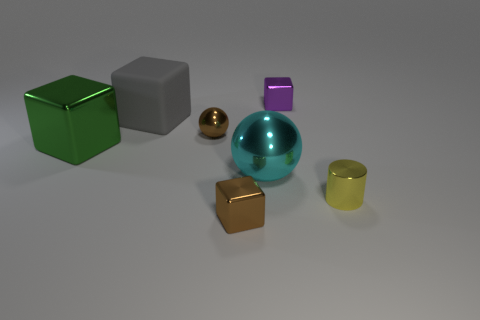What is the material of the brown object that is behind the shiny thing that is on the left side of the brown ball?
Give a very brief answer. Metal. There is a thing that is the same color as the small sphere; what is its material?
Your answer should be very brief. Metal. The big rubber block is what color?
Ensure brevity in your answer.  Gray. Is there a gray cube right of the small metallic cube behind the yellow metal object?
Your answer should be very brief. No. What is the large ball made of?
Your answer should be very brief. Metal. Is the material of the big cyan thing to the right of the big green shiny cube the same as the small cube to the left of the small purple metal cube?
Keep it short and to the point. Yes. Are there any other things that have the same color as the large metal block?
Ensure brevity in your answer.  No. There is another object that is the same shape as the cyan metallic object; what color is it?
Provide a short and direct response. Brown. There is a metal object that is both right of the big metallic ball and in front of the gray block; what size is it?
Provide a short and direct response. Small. Do the thing that is behind the gray block and the small object in front of the shiny cylinder have the same shape?
Your answer should be very brief. Yes. 